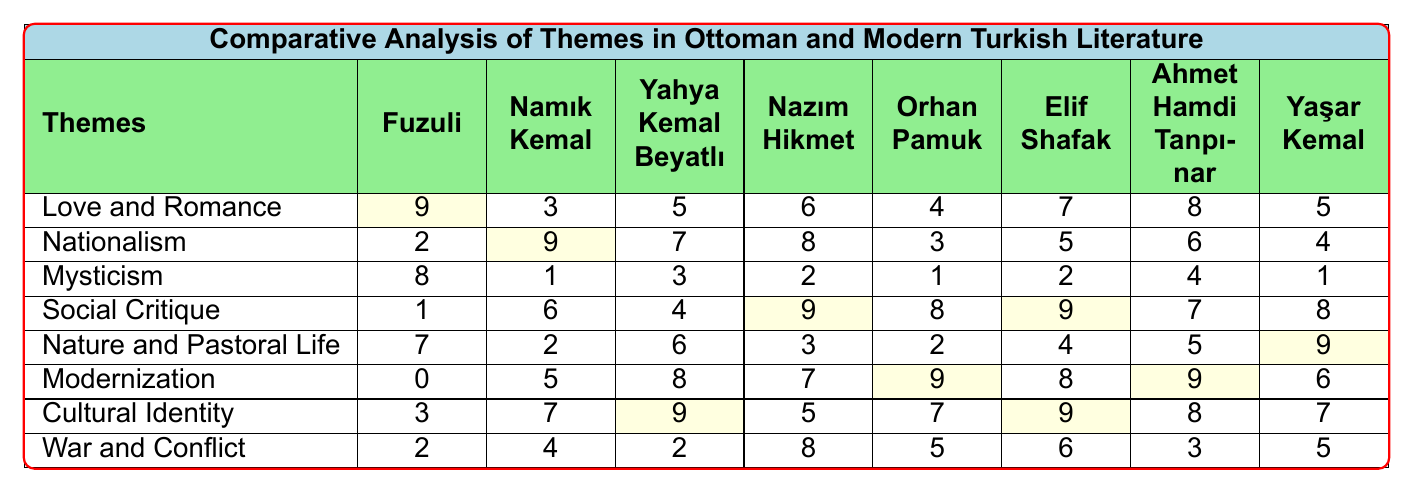What is the theme with the highest prevalence by Fuzuli? Looking at the row corresponding to Fuzuli, the highest number is 9, which corresponds to the theme "Love and Romance."
Answer: Love and Romance Which author has the highest prevalence for the theme of Nationalism? In the row for Nationalism, the highest number is 9, which is linked to the author Namık Kemal.
Answer: Namık Kemal Is there a theme where all authors scored zero prevalence? Reviewing the table, there are no themes with zero prevalence from any author; thus, the answer is false.
Answer: No What is the average prevalence of the theme "Social Critique"? Sum the values for "Social Critique": (1 + 6 + 4 + 9 + 8 + 9 + 7 + 8) = 52, and divide by the number of authors (8). The average is 52/8 = 6.5.
Answer: 6.5 Which author scored the lowest for the theme of War and Conflict? Checking the row for War and Conflict, the lowest score is 2, which is attributed to both Fuzuli and Yahya Kemal Beyatlı.
Answer: Fuzuli and Yahya Kemal Beyatlı How does the prevalence of the theme "Modernization" compare between Elif Shafak and Orhan Pamuk? Elif Shafak has a prevalence of 8 for "Modernization," while Orhan Pamuk has a score of 9. Thus, Orhan Pamuk has a higher prevalence.
Answer: Orhan Pamuk has a higher prevalence What is the total prevalence for the theme "Love and Romance"? Summing the prevalence for "Love and Romance": (9 + 3 + 5 + 6 + 4 + 7 + 8 + 5) = 47.
Answer: 47 Are there more authors that show a higher prevalence for "Cultural Identity" compared to "Mysticism"? For "Cultural Identity", the high score is 9 with results for three authors, while "Mysticism" only reaches a maximum of 8 with just one author scoring this high. Thus, the answer is yes.
Answer: Yes What is the combined prevalence of "Nature and Pastoral Life" and "War and Conflict" for Nazım Hikmet? Nazım Hikmet's scores for these themes are 3 (Nature and Pastoral Life) and 8 (War and Conflict). The combined total is 3 + 8 = 11.
Answer: 11 Which theme had the highest overall prevalence across all authors? By analyzing the rows, adding individual scores for each theme identifies "Love and Romance" with a total of 9 + 3 + 5 + 6 + 4 + 7 + 8 + 5 = 47; therefore, this is the highest.
Answer: Love and Romance Who has the highest prevalence for the theme "Cultural Identity"? Reviewing the scores for "Cultural Identity," the highest value is 9, which is achieved by Yahya Kemal Beyatlı and Elif Shafak, thus both share this distinction.
Answer: Yahya Kemal Beyatlı and Elif Shafak 